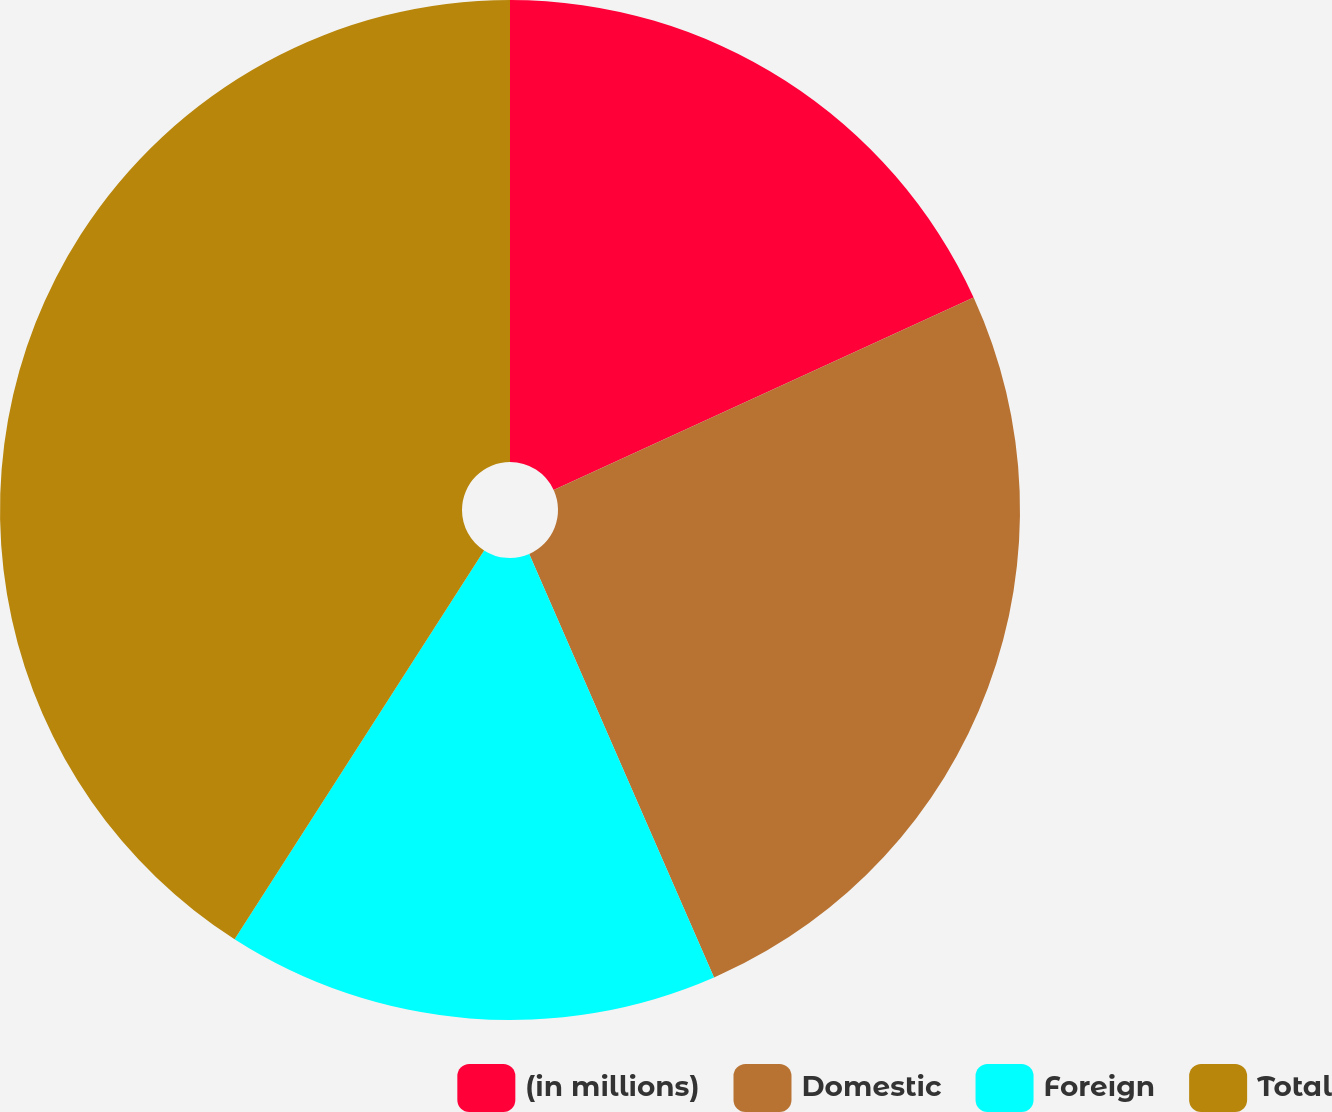Convert chart. <chart><loc_0><loc_0><loc_500><loc_500><pie_chart><fcel>(in millions)<fcel>Domestic<fcel>Foreign<fcel>Total<nl><fcel>18.16%<fcel>25.29%<fcel>15.63%<fcel>40.92%<nl></chart> 